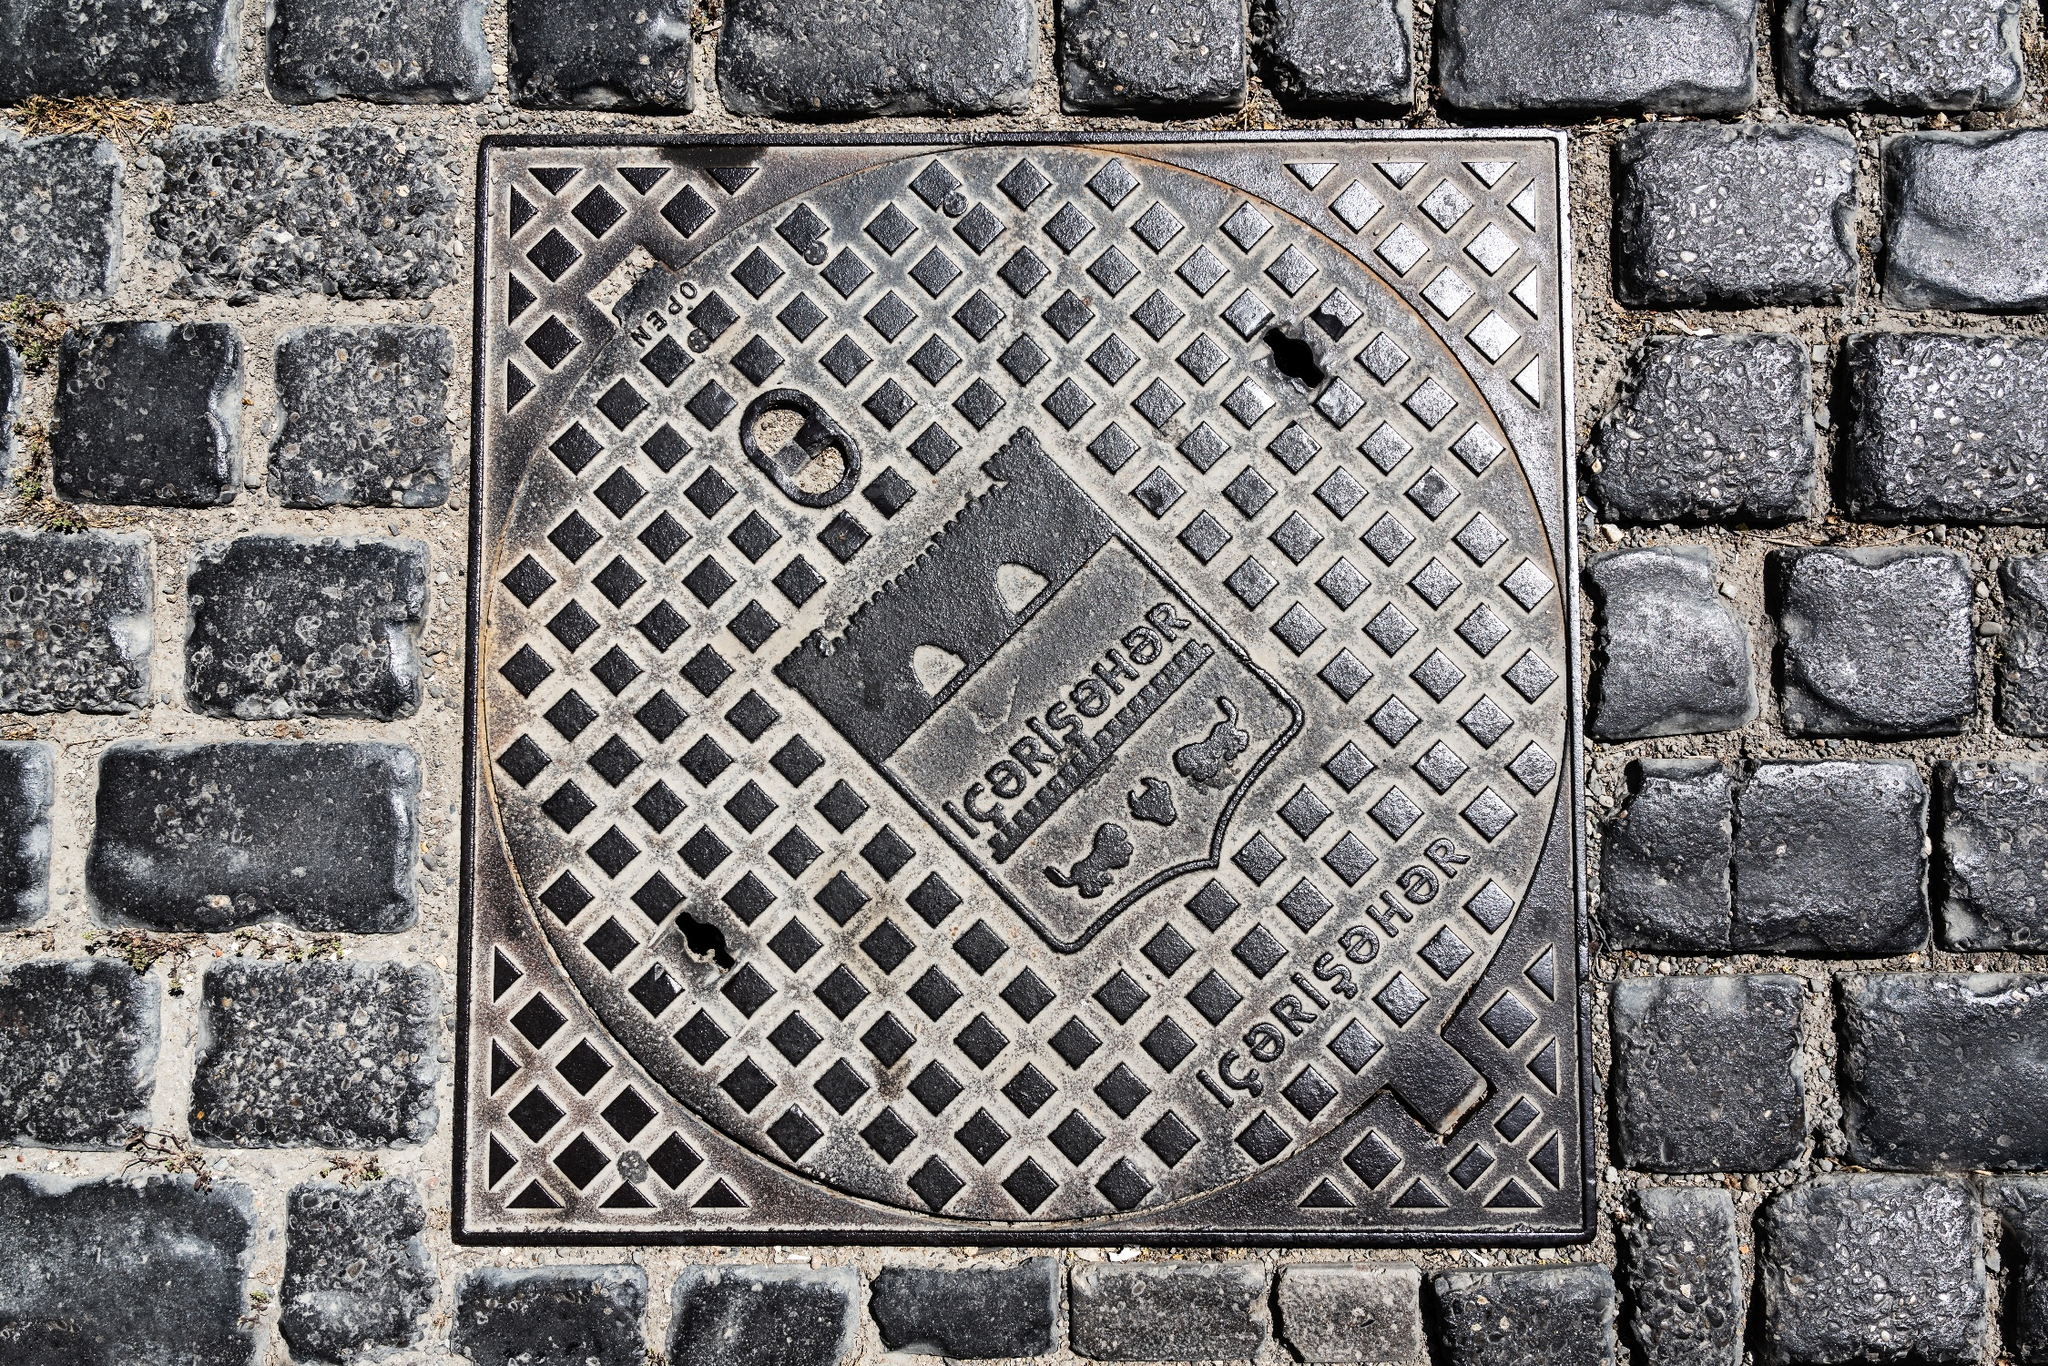Describe the following image. The image you've shared is of a square manhole cover situated on a cobblestone street. The manhole cover, made of metal, features an intricate geometric pattern that adds a touch of artistry to its otherwise utilitarian purpose. The words "GORENJE" and "GORENJE GORENJE" are prominently displayed on the cover, suggesting the manufacturer's name or perhaps the location. The cover shows signs of wear and tear, with patches of rust visible, indicating its age and constant exposure to the elements. The street itself is paved with gray cobblestones, their uneven surface filled with moss, adding a touch of nature to the urban setting. The perspective of the image suggests it was taken from a standing position, looking directly down at the manhole cover, capturing the details of both the cover and the surrounding cobblestones. 